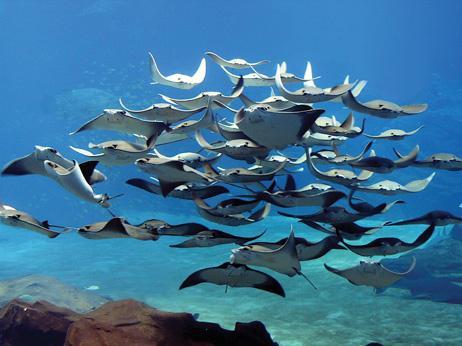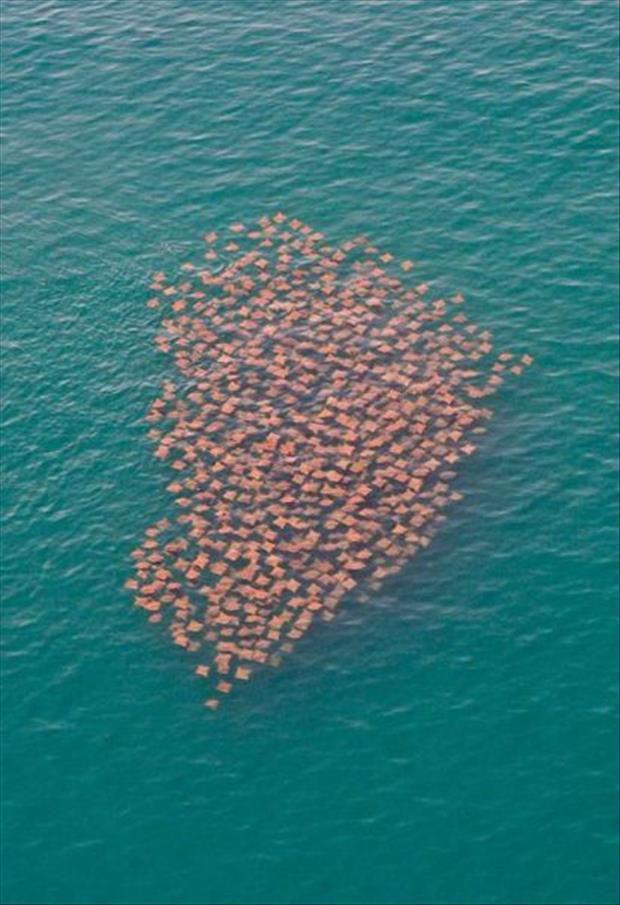The first image is the image on the left, the second image is the image on the right. Given the left and right images, does the statement "There are exactly two animals in the image on the left." hold true? Answer yes or no. No. The first image is the image on the left, the second image is the image on the right. For the images displayed, is the sentence "There are no more than two stingrays." factually correct? Answer yes or no. No. 